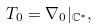Convert formula to latex. <formula><loc_0><loc_0><loc_500><loc_500>T _ { 0 } = \nabla _ { 0 } | _ { \mathbb { C } ^ { \ast } } ,</formula> 